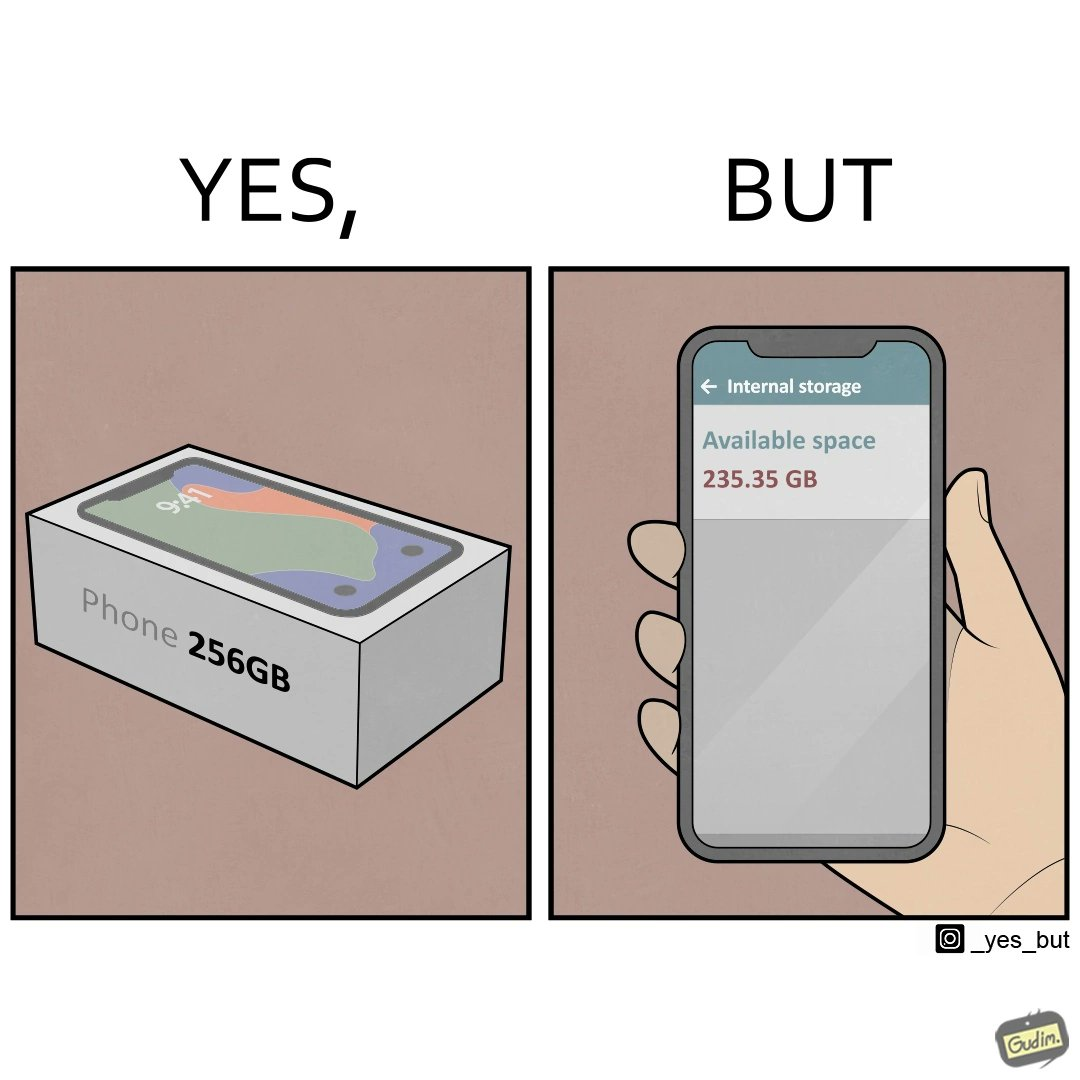Describe the satirical element in this image. The images are funny since they show how smartphone manufacturers advertise their smartphones to have a high internal storage space but in reality, the amount of space available to an user is considerably less due to pre-installed software 